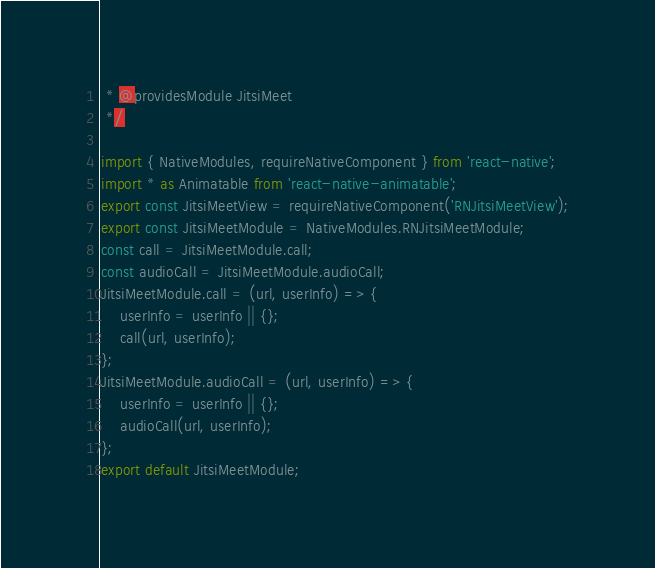<code> <loc_0><loc_0><loc_500><loc_500><_JavaScript_> * @providesModule JitsiMeet
 */

import { NativeModules, requireNativeComponent } from 'react-native';
import * as Animatable from 'react-native-animatable';
export const JitsiMeetView = requireNativeComponent('RNJitsiMeetView');
export const JitsiMeetModule = NativeModules.RNJitsiMeetModule;
const call = JitsiMeetModule.call;
const audioCall = JitsiMeetModule.audioCall;
JitsiMeetModule.call = (url, userInfo) => {
	userInfo = userInfo || {};
	call(url, userInfo);
};
JitsiMeetModule.audioCall = (url, userInfo) => {
	userInfo = userInfo || {};
	audioCall(url, userInfo);
};
export default JitsiMeetModule;
</code> 